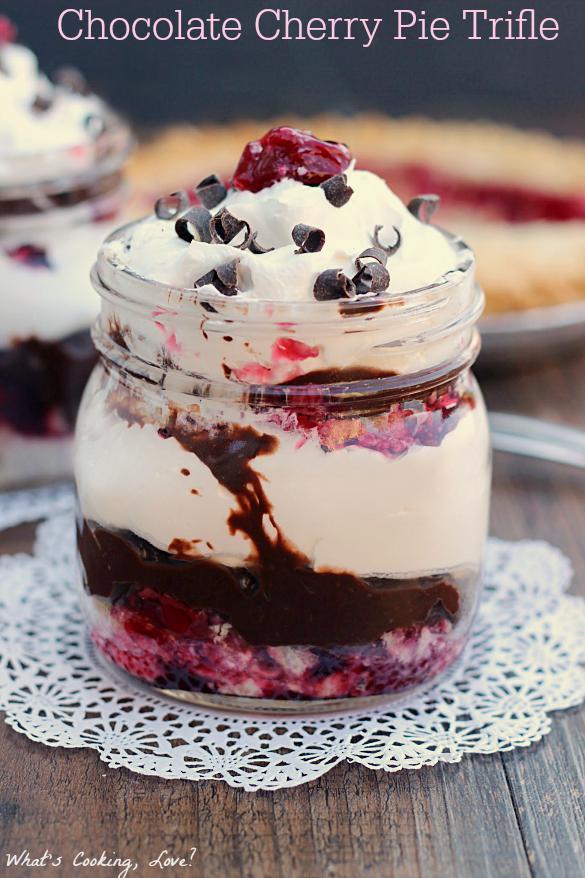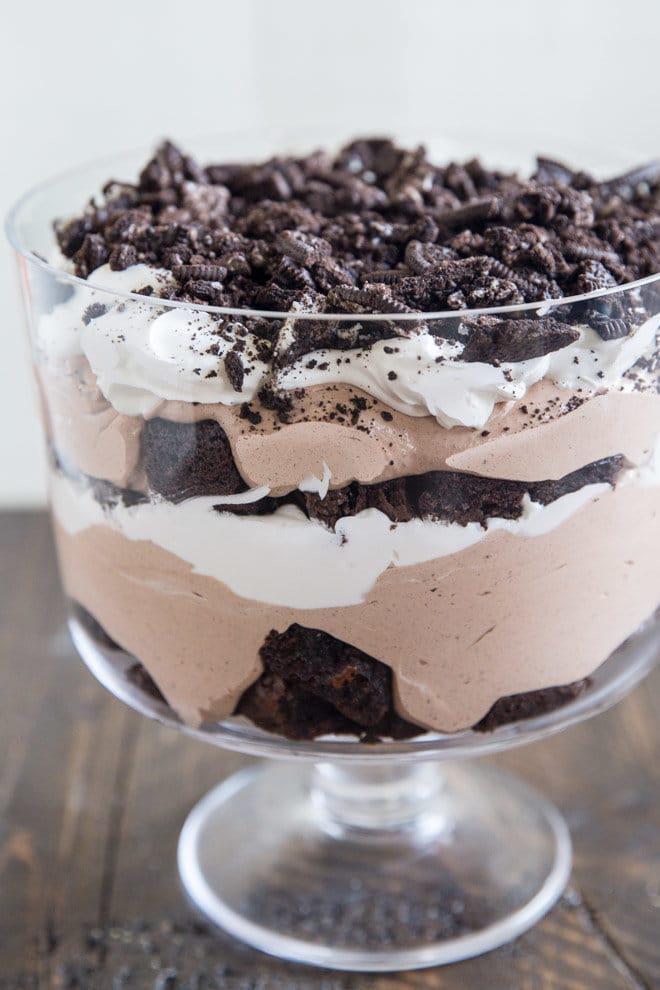The first image is the image on the left, the second image is the image on the right. Given the left and right images, does the statement "In one image, a large layered dessert with chocolate garnish is made in a clear glass footed bowl, while a second image shows one or more individual desserts made with red berries." hold true? Answer yes or no. Yes. The first image is the image on the left, the second image is the image on the right. Given the left and right images, does the statement "One image shows a dessert with no reddish-purple layer served in one footed glass, and the other shows a non-footed glass containing a reddish-purple layer." hold true? Answer yes or no. Yes. 